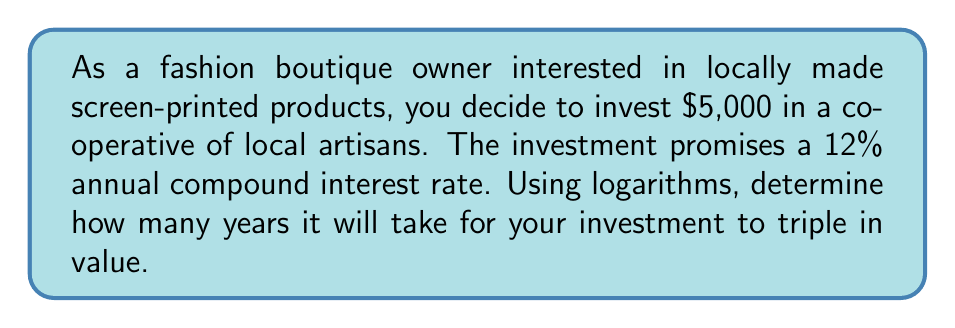Could you help me with this problem? To solve this problem, we'll use the compound interest formula and logarithms:

1) The compound interest formula is:
   $$A = P(1 + r)^t$$
   where $A$ is the final amount, $P$ is the principal (initial investment), $r$ is the annual interest rate, and $t$ is the time in years.

2) We want to find when the investment triples, so:
   $$3P = P(1 + r)^t$$

3) Simplify by dividing both sides by $P$:
   $$3 = (1 + r)^t$$

4) Take the natural logarithm of both sides:
   $$\ln(3) = \ln((1 + r)^t)$$

5) Use the logarithm property $\ln(a^b) = b\ln(a)$:
   $$\ln(3) = t\ln(1 + r)$$

6) Solve for $t$ by dividing both sides by $\ln(1 + r)$:
   $$t = \frac{\ln(3)}{\ln(1 + r)}$$

7) Now, substitute the given values:
   $r = 0.12$ (12% as a decimal)

   $$t = \frac{\ln(3)}{\ln(1 + 0.12)}$$

8) Calculate:
   $$t = \frac{\ln(3)}{\ln(1.12)} \approx 9.5831$$

9) Round to two decimal places:
   $$t \approx 9.58 \text{ years}$$
Answer: It will take approximately 9.58 years for the $5,000 investment to triple in value at a 12% annual compound interest rate. 